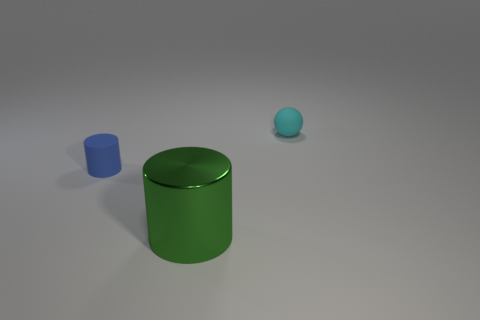Add 3 green shiny blocks. How many objects exist? 6 Subtract all cylinders. How many objects are left? 1 Add 3 small objects. How many small objects exist? 5 Subtract 0 gray balls. How many objects are left? 3 Subtract all small things. Subtract all cyan matte spheres. How many objects are left? 0 Add 2 big metallic cylinders. How many big metallic cylinders are left? 3 